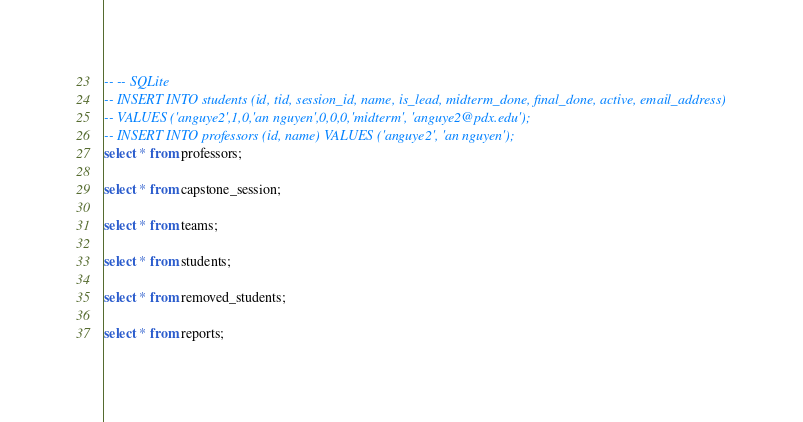Convert code to text. <code><loc_0><loc_0><loc_500><loc_500><_SQL_>-- -- SQLite
-- INSERT INTO students (id, tid, session_id, name, is_lead, midterm_done, final_done, active, email_address)
-- VALUES ('anguye2',1,0,'an nguyen',0,0,0,'midterm', 'anguye2@pdx.edu');
-- INSERT INTO professors (id, name) VALUES ('anguye2', 'an nguyen');
select * from professors;

select * from capstone_session;

select * from teams;

select * from students;

select * from removed_students;

select * from reports;
</code> 